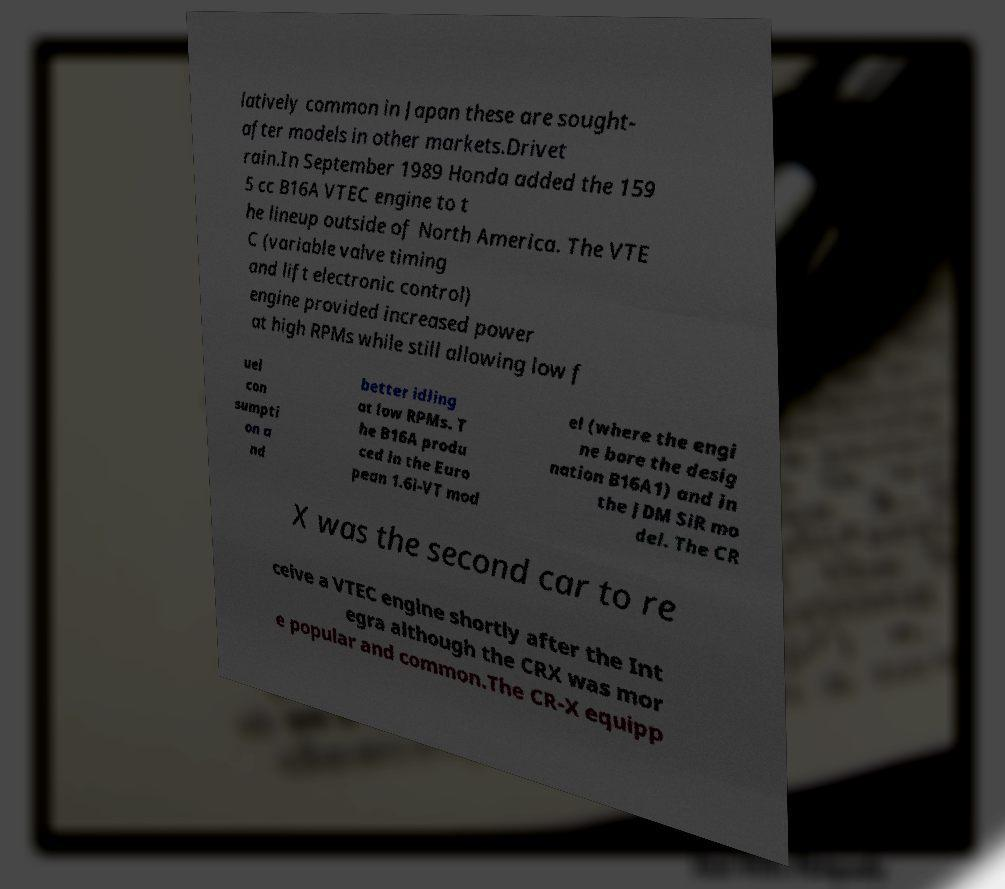I need the written content from this picture converted into text. Can you do that? latively common in Japan these are sought- after models in other markets.Drivet rain.In September 1989 Honda added the 159 5 cc B16A VTEC engine to t he lineup outside of North America. The VTE C (variable valve timing and lift electronic control) engine provided increased power at high RPMs while still allowing low f uel con sumpti on a nd better idling at low RPMs. T he B16A produ ced in the Euro pean 1.6i-VT mod el (where the engi ne bore the desig nation B16A1) and in the JDM SiR mo del. The CR X was the second car to re ceive a VTEC engine shortly after the Int egra although the CRX was mor e popular and common.The CR-X equipp 